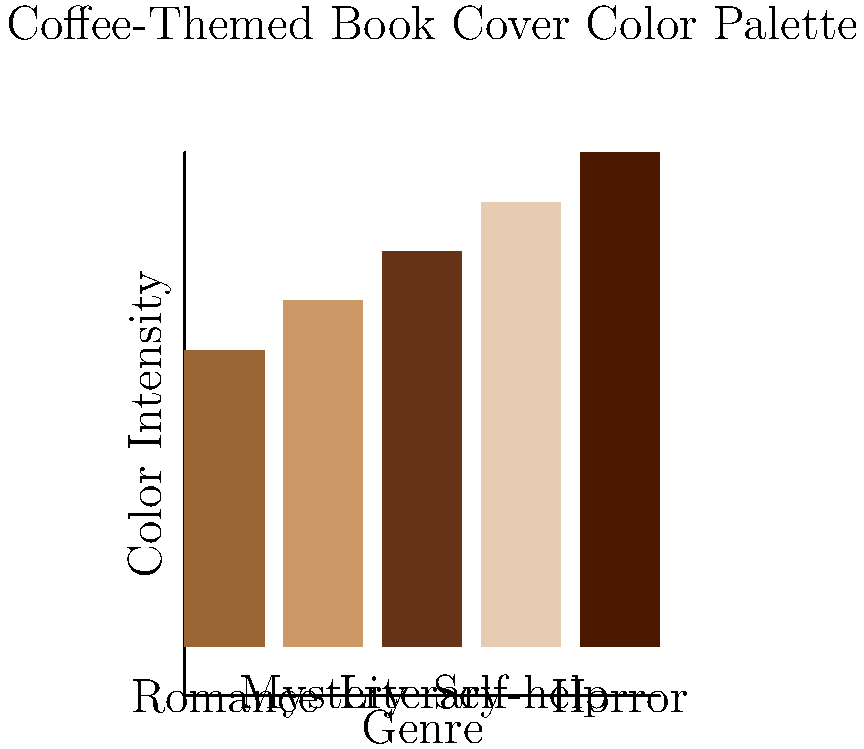Based on the color palette analysis of coffee-themed book covers across different genres, which genre tends to use the darkest shades of brown in its cover designs? To answer this question, we need to analyze the color intensity for each genre represented in the bar chart:

1. Romance: Light to medium brown (rgb(0.6,0.4,0.2))
2. Mystery: Medium brown (rgb(0.8,0.6,0.4))
3. Literary: Dark brown (rgb(0.4,0.2,0.1))
4. Self-help: Very light brown or beige (rgb(0.9,0.8,0.7))
5. Horror: Very dark brown, almost black (rgb(0.3,0.1,0))

The darkest shade of brown is represented by the lowest RGB values, as lower numbers indicate less light and thus a darker color. Comparing the RGB values:

- Romance: (0.6,0.4,0.2)
- Mystery: (0.8,0.6,0.4)
- Literary: (0.4,0.2,0.1)
- Self-help: (0.9,0.8,0.7)
- Horror: (0.3,0.1,0)

The Horror genre has the lowest RGB values (0.3,0.1,0), indicating the darkest shade of brown among all genres represented.
Answer: Horror 